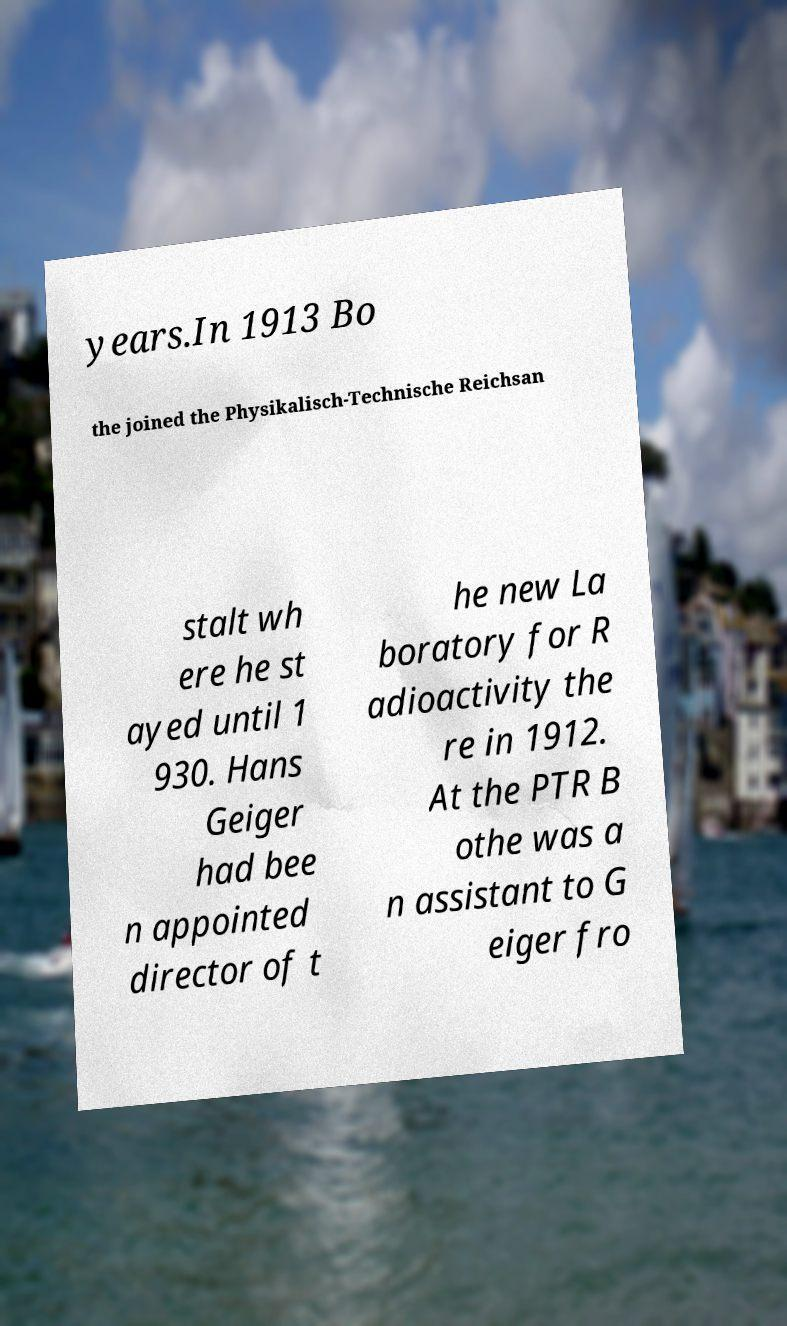Please read and relay the text visible in this image. What does it say? years.In 1913 Bo the joined the Physikalisch-Technische Reichsan stalt wh ere he st ayed until 1 930. Hans Geiger had bee n appointed director of t he new La boratory for R adioactivity the re in 1912. At the PTR B othe was a n assistant to G eiger fro 